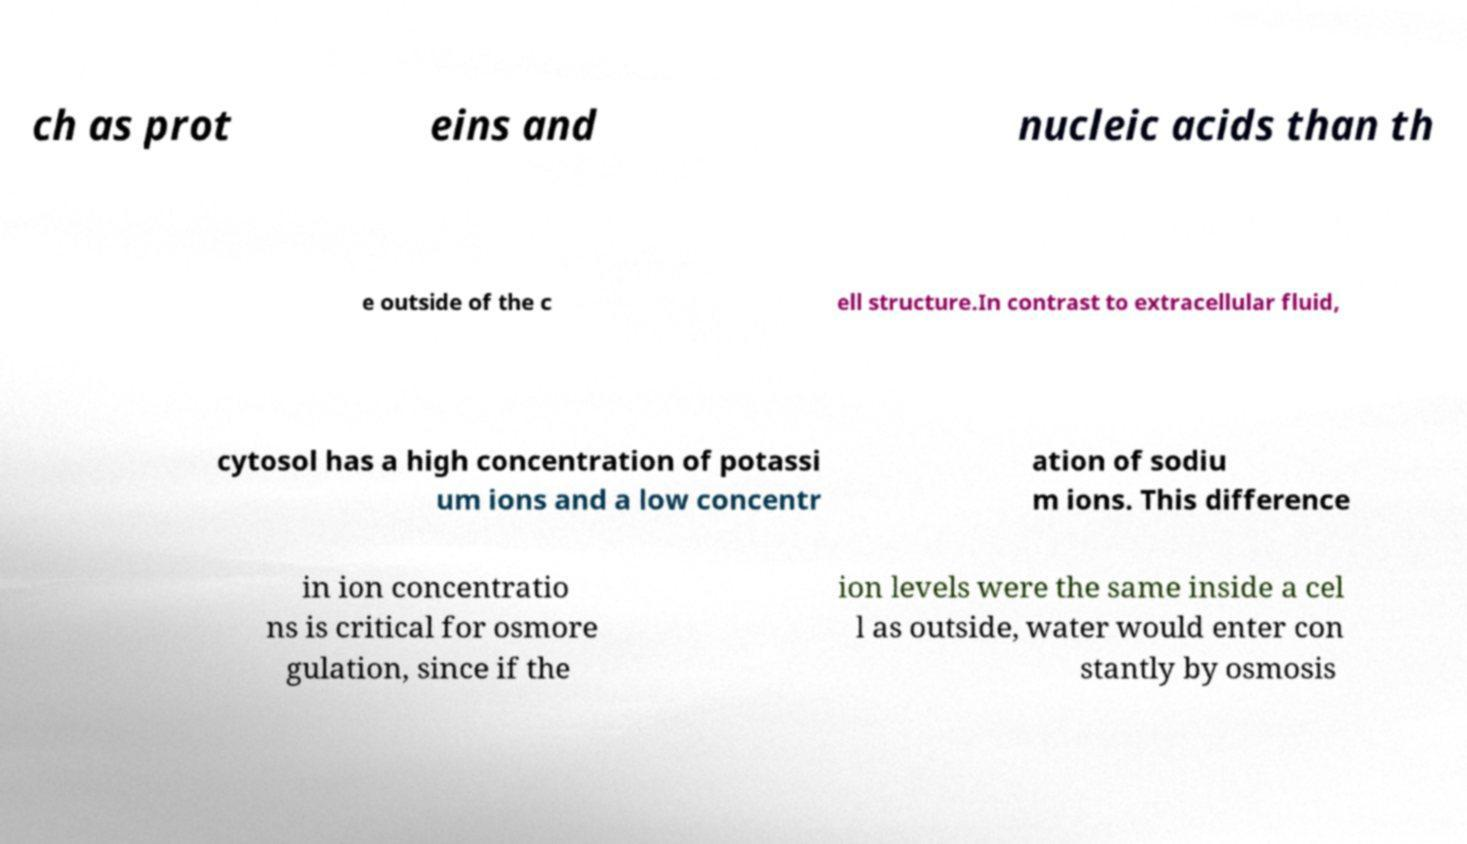I need the written content from this picture converted into text. Can you do that? ch as prot eins and nucleic acids than th e outside of the c ell structure.In contrast to extracellular fluid, cytosol has a high concentration of potassi um ions and a low concentr ation of sodiu m ions. This difference in ion concentratio ns is critical for osmore gulation, since if the ion levels were the same inside a cel l as outside, water would enter con stantly by osmosis 